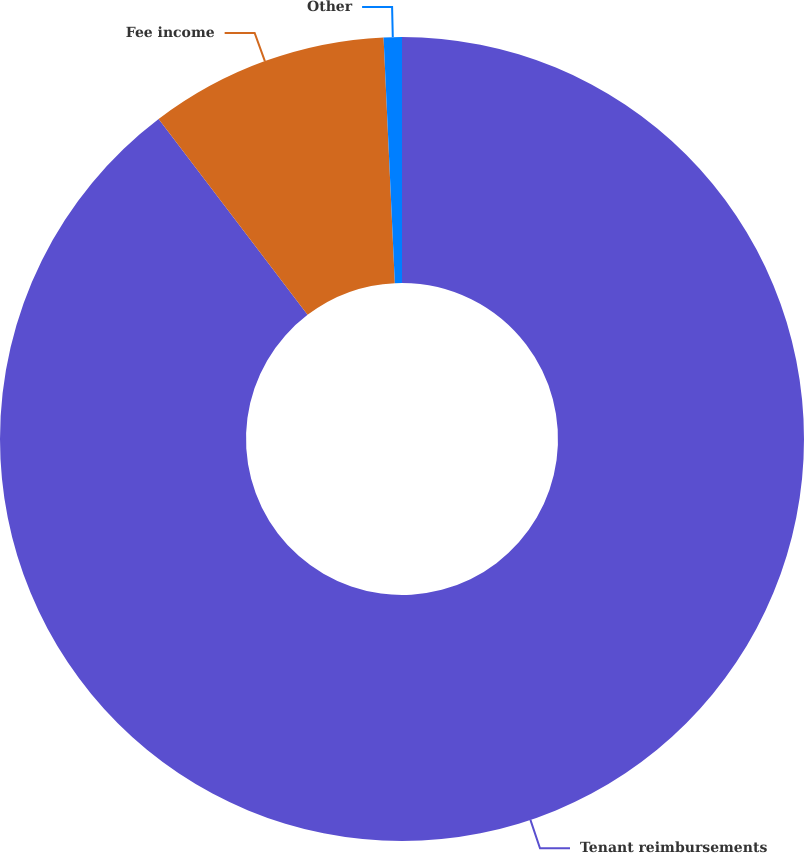Convert chart. <chart><loc_0><loc_0><loc_500><loc_500><pie_chart><fcel>Tenant reimbursements<fcel>Fee income<fcel>Other<nl><fcel>89.65%<fcel>9.62%<fcel>0.73%<nl></chart> 